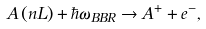Convert formula to latex. <formula><loc_0><loc_0><loc_500><loc_500>A \left ( { n L } \right ) + \hbar { \omega } _ { B B R } \to A ^ { + } + e ^ { - } ,</formula> 